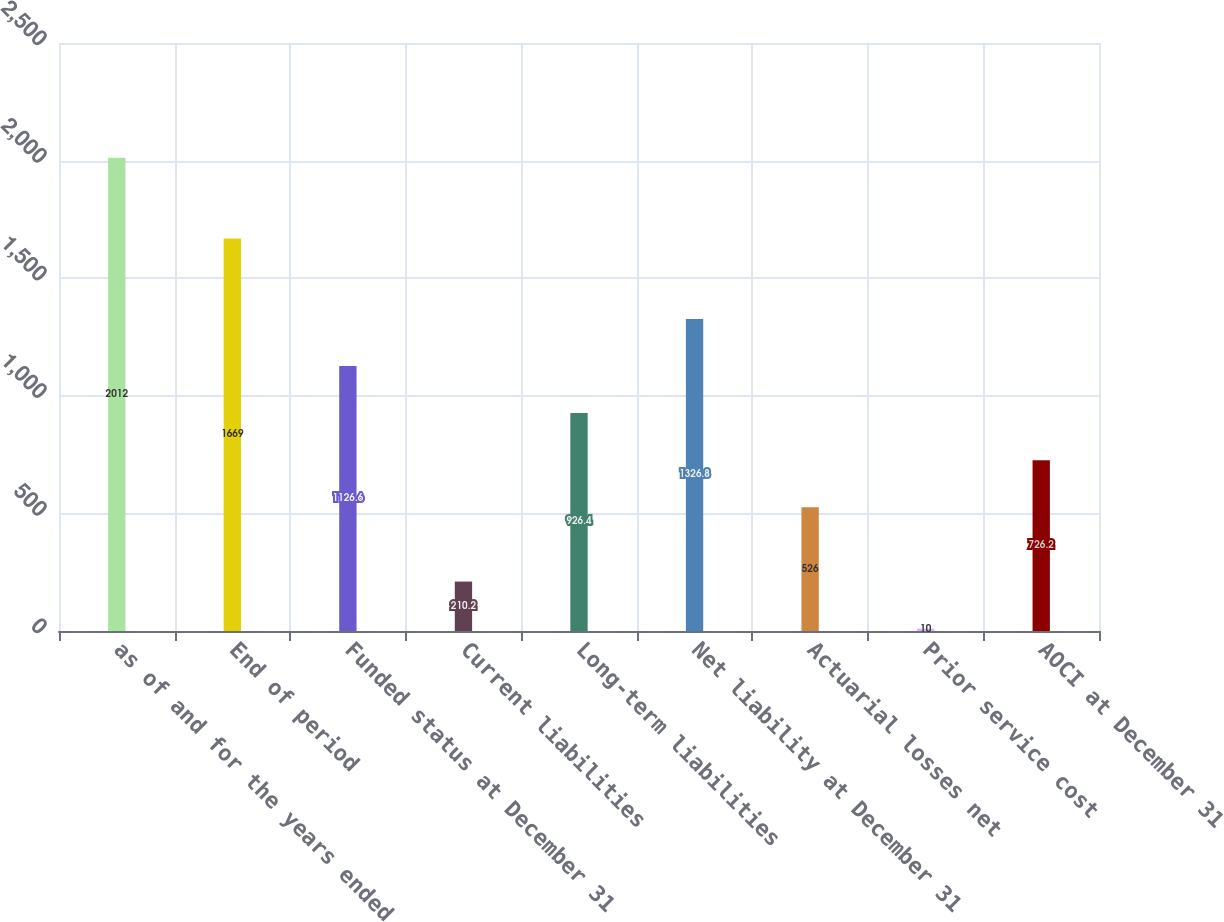<chart> <loc_0><loc_0><loc_500><loc_500><bar_chart><fcel>as of and for the years ended<fcel>End of period<fcel>Funded status at December 31<fcel>Current liabilities<fcel>Long-term liabilities<fcel>Net liability at December 31<fcel>Actuarial losses net<fcel>Prior service cost<fcel>AOCI at December 31<nl><fcel>2012<fcel>1669<fcel>1126.6<fcel>210.2<fcel>926.4<fcel>1326.8<fcel>526<fcel>10<fcel>726.2<nl></chart> 